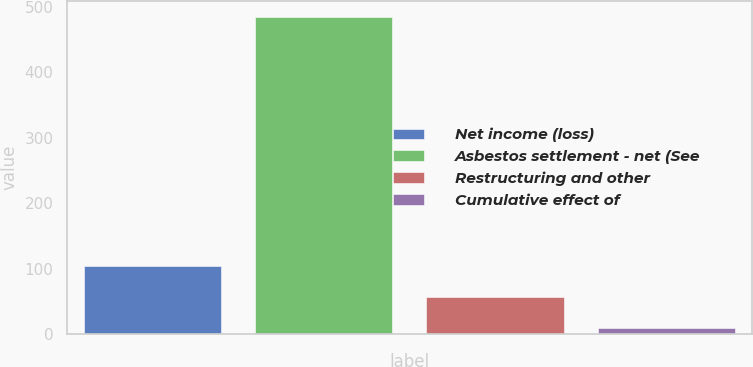<chart> <loc_0><loc_0><loc_500><loc_500><bar_chart><fcel>Net income (loss)<fcel>Asbestos settlement - net (See<fcel>Restructuring and other<fcel>Cumulative effect of<nl><fcel>104<fcel>484<fcel>56.5<fcel>9<nl></chart> 